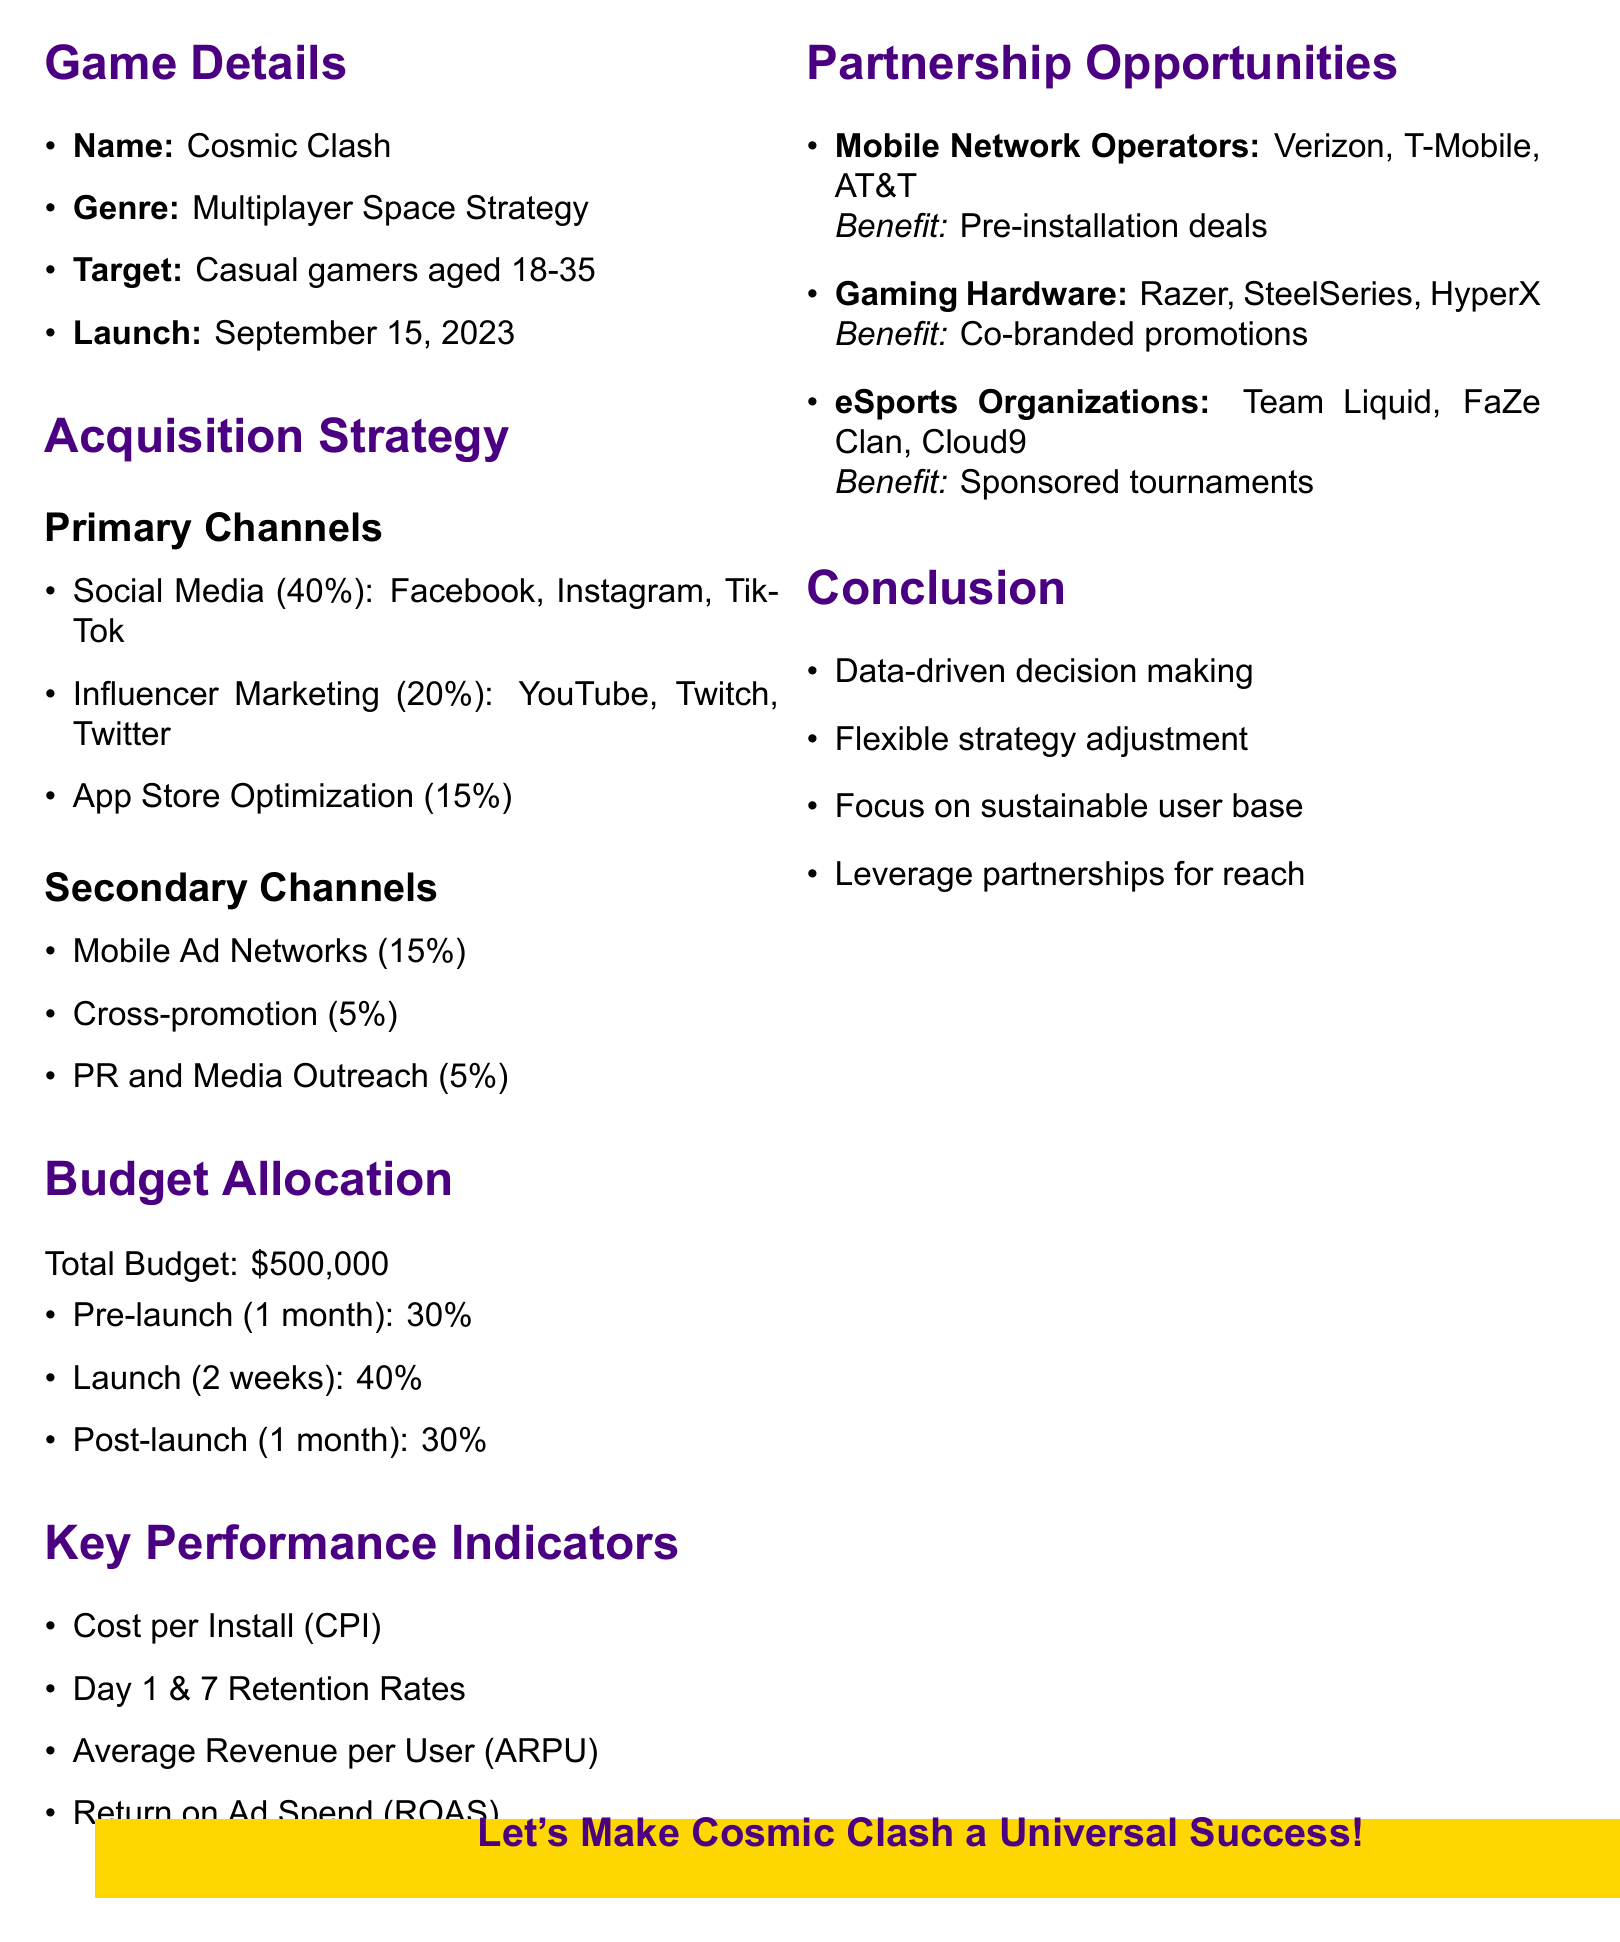What is the name of the game? The name of the game is stated in the game details section of the document.
Answer: Cosmic Clash What is the allocated budget for social media advertising? The allocated budget for social media advertising is specified under primary channels in the user acquisition strategy.
Answer: 40% of total budget Which platforms are included in influencer marketing? The platforms for influencer marketing are listed under the related channel in the acquisition strategy section.
Answer: YouTube, Twitch, Twitter What percentage of the budget is allocated for the launch phase? The budget allocation for each phase is provided in the budget allocation section of the document.
Answer: 40% of total budget How long is the post-launch phase? The duration of the post-launch phase is mentioned in the budget allocation breakdown.
Answer: 1 month Which potential partners are listed for mobile network operators? The document names specific potential partners for mobile network operators in the partnership opportunities section.
Answer: Verizon, T-Mobile, AT&T What is one of the key performance indicators listed? The key performance indicators are outlined in a list format within the document.
Answer: Cost per Install (CPI) What is emphasized in the conclusion of the memo? The conclusion points summarize key takeaways from the document emphasizing specific strategies.
Answer: Data-driven decision making What is the target audience for "Cosmic Clash"? The target audience is specified in the game details section of the document.
Answer: Casual gamers aged 18-35 